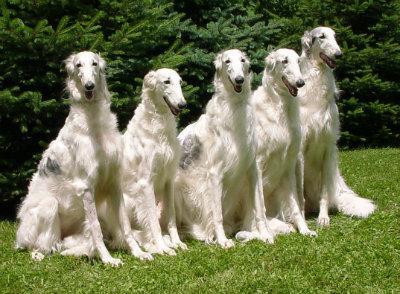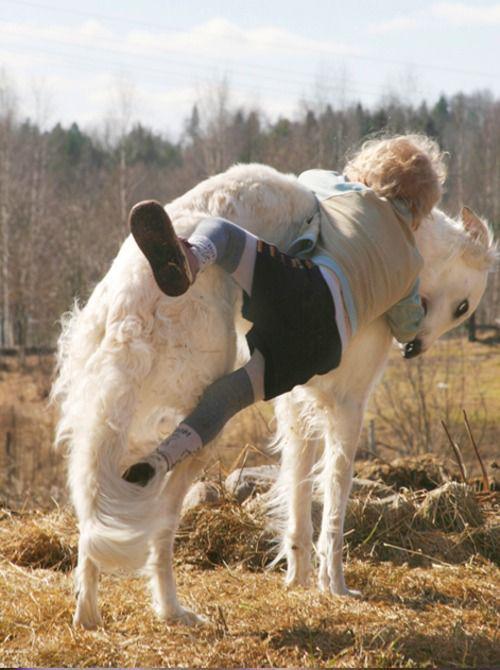The first image is the image on the left, the second image is the image on the right. Evaluate the accuracy of this statement regarding the images: "An image shows a young animal of some type close to an adult hound with its body turned rightward.". Is it true? Answer yes or no. Yes. The first image is the image on the left, the second image is the image on the right. Evaluate the accuracy of this statement regarding the images: "There is one dog in a grassy area in the image on the left.". Is it true? Answer yes or no. No. 